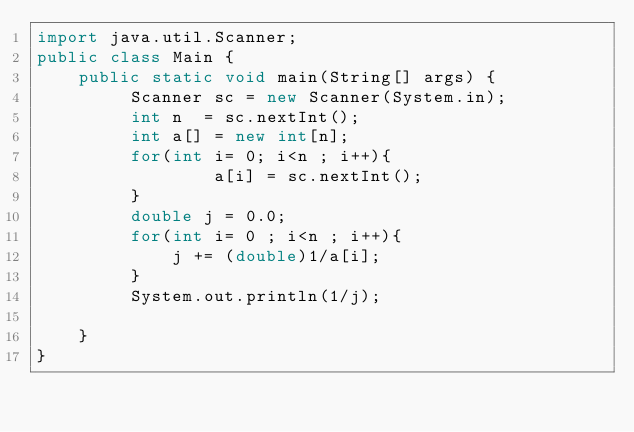Convert code to text. <code><loc_0><loc_0><loc_500><loc_500><_Java_>import java.util.Scanner;
public class Main {
    public static void main(String[] args) {
         Scanner sc = new Scanner(System.in);
         int n  = sc.nextInt();
         int a[] = new int[n];
         for(int i= 0; i<n ; i++){
                 a[i] = sc.nextInt();
         }
         double j = 0.0;
         for(int i= 0 ; i<n ; i++){
             j += (double)1/a[i];
         }
         System.out.println(1/j);
         
    }
}
</code> 